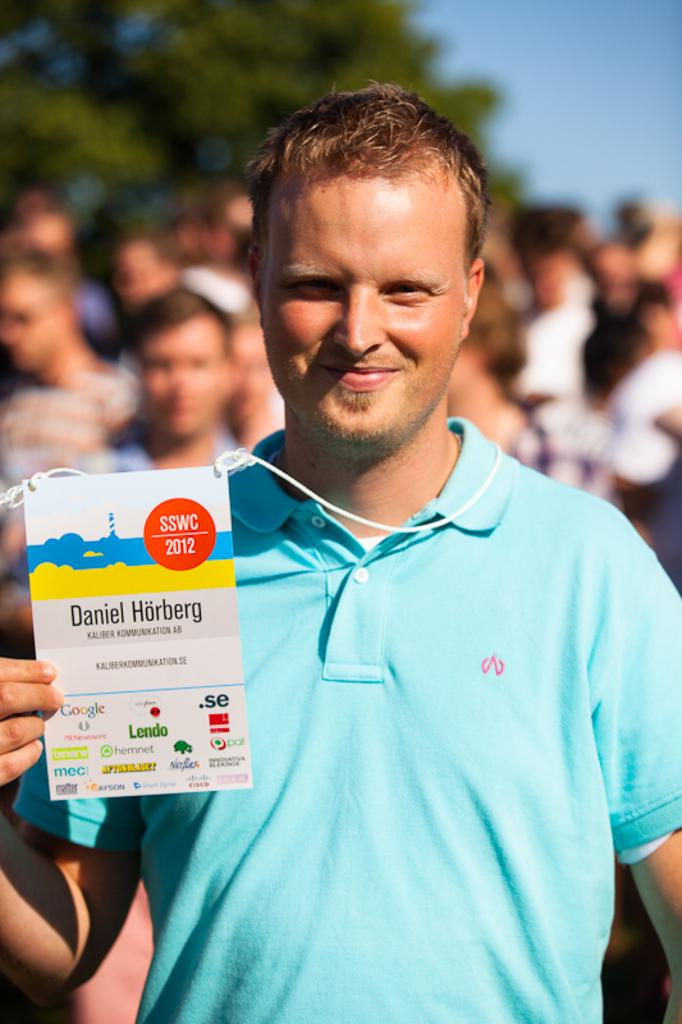What is the person in the image doing? The person is standing in the image and holding an ID card in his hand. Are there any other people in the image? Yes, there are other people standing in the image. Can you describe the condition of the image? The image is blurry at the back. What type of disease is the scarecrow suffering from in the image? There is no scarecrow present in the image, and therefore no disease can be associated with it. 